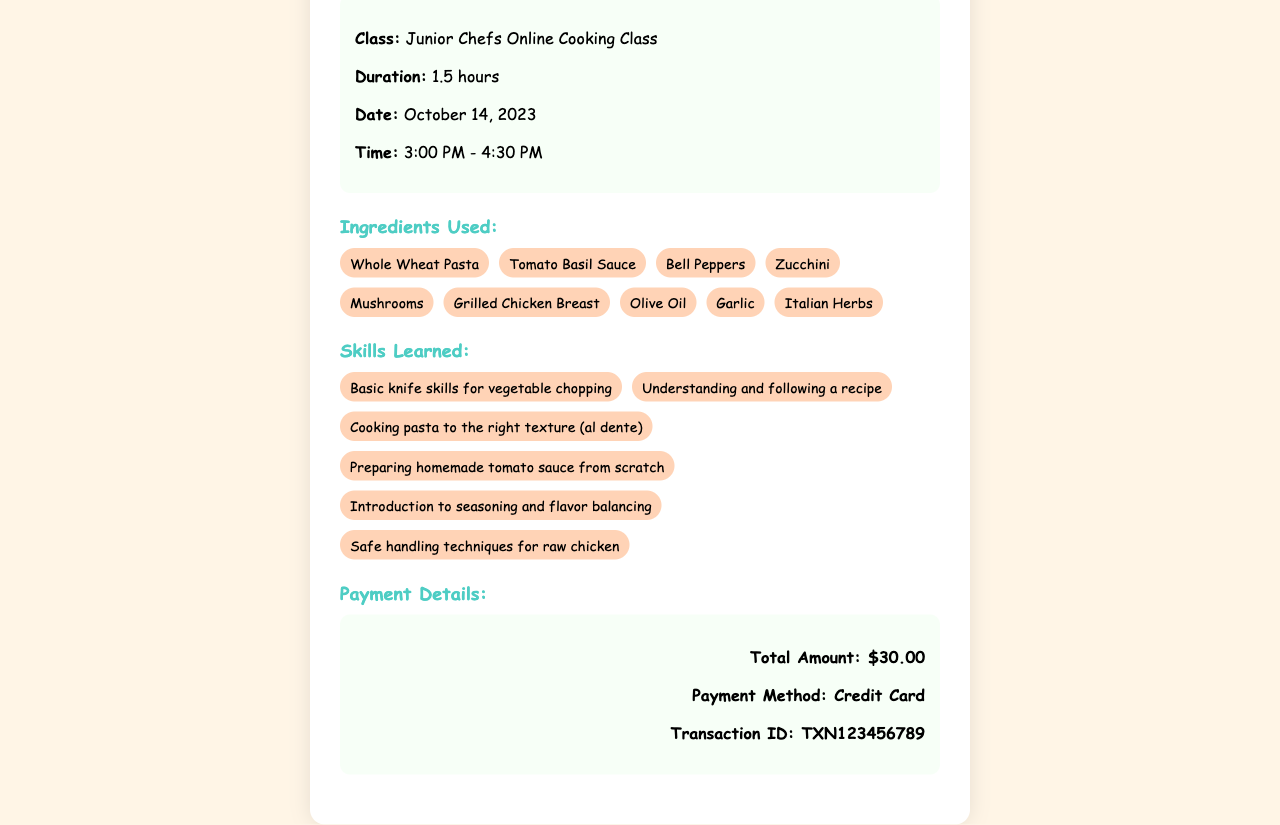What is the class duration? The class duration is explicitly stated in the document as 1.5 hours.
Answer: 1.5 hours What date was the cooking class held? The date of the cooking class is mentioned in the document as October 14, 2023.
Answer: October 14, 2023 What is the total amount paid for the cooking class? The total amount indicated in the payment details section is $30.00.
Answer: $30.00 List one ingredient used in the class. The document provides a list of ingredients, one of which is Whole Wheat Pasta.
Answer: Whole Wheat Pasta What skill involves preparing homemade tomato sauce? One of the skills learned involves "Preparing homemade tomato sauce from scratch," which is highlighted in the skills section.
Answer: Preparing homemade tomato sauce from scratch What time did the class start? The start time of the class is listed as 3:00 PM in the document.
Answer: 3:00 PM How many skills were learned during the session? The document outlines a total of six unique skills learned during the session.
Answer: Six What payment method was used? The receipt indicates that the payment method used was a credit card.
Answer: Credit Card What is the transaction ID? The transaction ID can be found in the payment details section as TXN123456789.
Answer: TXN123456789 